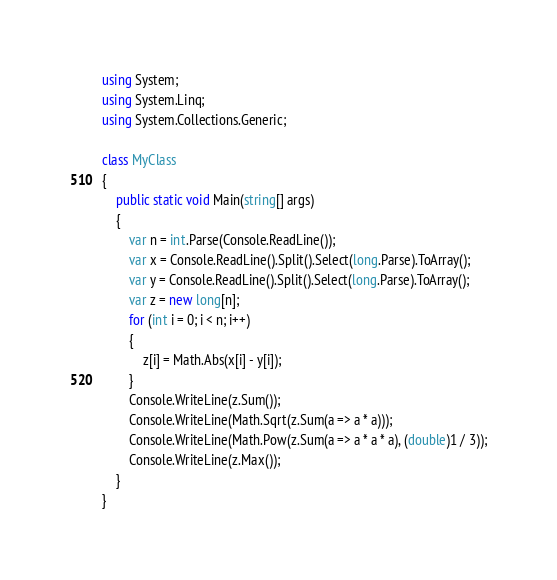Convert code to text. <code><loc_0><loc_0><loc_500><loc_500><_C#_>using System;
using System.Linq;
using System.Collections.Generic;

class MyClass
{
    public static void Main(string[] args)
    {
        var n = int.Parse(Console.ReadLine());
        var x = Console.ReadLine().Split().Select(long.Parse).ToArray();
        var y = Console.ReadLine().Split().Select(long.Parse).ToArray();
        var z = new long[n];
        for (int i = 0; i < n; i++)
        {
            z[i] = Math.Abs(x[i] - y[i]);
        }
        Console.WriteLine(z.Sum());
        Console.WriteLine(Math.Sqrt(z.Sum(a => a * a)));
        Console.WriteLine(Math.Pow(z.Sum(a => a * a * a), (double)1 / 3));
        Console.WriteLine(z.Max());
    }
}
</code> 